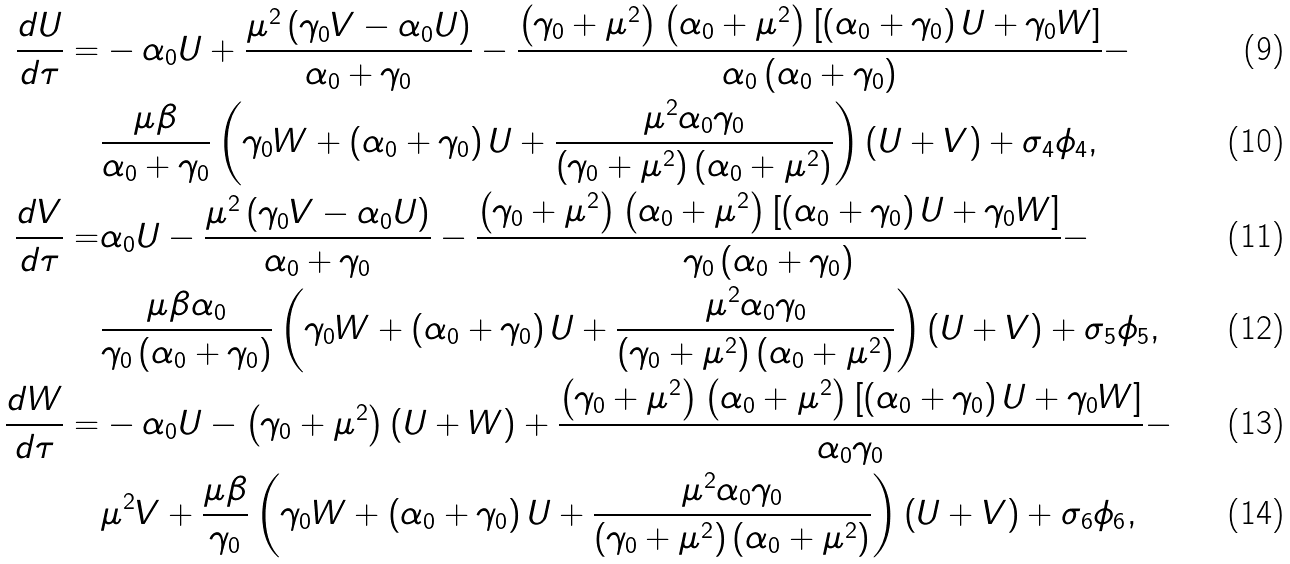Convert formula to latex. <formula><loc_0><loc_0><loc_500><loc_500>\frac { d U } { d \tau } = & - \alpha _ { 0 } U + { \frac { \mu ^ { 2 } \left ( \gamma _ { 0 } V - \alpha _ { 0 } U \right ) } { \alpha _ { 0 } + \gamma _ { 0 } } } - { \frac { \left ( \gamma _ { 0 } + \mu ^ { 2 } \right ) \left ( \alpha _ { 0 } + \mu ^ { 2 } \right ) \left [ \left ( \alpha _ { 0 } + \gamma _ { 0 } \right ) U + \gamma _ { 0 } W \right ] } { \alpha _ { 0 } \left ( \alpha _ { 0 } + \gamma _ { 0 } \right ) } } - \\ & \frac { \mu \beta } { \alpha _ { 0 } + \gamma _ { 0 } } \left ( \gamma _ { 0 } W + \left ( \alpha _ { 0 } + \gamma _ { 0 } \right ) U + { \frac { \mu ^ { 2 } \alpha _ { 0 } \gamma _ { 0 } } { \left ( \gamma _ { 0 } + \mu ^ { 2 } \right ) \left ( \alpha _ { 0 } + \mu ^ { 2 } \right ) } } \right ) \left ( U + V \right ) + \sigma _ { 4 } \phi _ { 4 } , \\ \frac { d V } { d \tau } = & \alpha _ { 0 } U - { \frac { \mu ^ { 2 } \left ( \gamma _ { 0 } V - \alpha _ { 0 } U \right ) } { \alpha _ { 0 } + \gamma _ { 0 } } } - { \frac { \left ( \gamma _ { 0 } + \mu ^ { 2 } \right ) \left ( \alpha _ { 0 } + \mu ^ { 2 } \right ) \left [ \left ( \alpha _ { 0 } + \gamma _ { 0 } \right ) U + \gamma _ { 0 } W \right ] } { \gamma _ { 0 } \left ( \alpha _ { 0 } + \gamma _ { 0 } \right ) } } - \\ & \frac { \mu \beta \alpha _ { 0 } } { \gamma _ { 0 } \left ( \alpha _ { 0 } + \gamma _ { 0 } \right ) } \left ( \gamma _ { 0 } W + \left ( \alpha _ { 0 } + \gamma _ { 0 } \right ) U + { \frac { \mu ^ { 2 } \alpha _ { 0 } \gamma _ { 0 } } { \left ( \gamma _ { 0 } + \mu ^ { 2 } \right ) \left ( \alpha _ { 0 } + \mu ^ { 2 } \right ) } } \right ) \left ( U + V \right ) + \sigma _ { 5 } \phi _ { 5 } , \\ \frac { d W } { d \tau } = & - \alpha _ { 0 } U - \left ( \gamma _ { 0 } + \mu ^ { 2 } \right ) \left ( U + W \right ) + { \frac { \left ( \gamma _ { 0 } + \mu ^ { 2 } \right ) \left ( \alpha _ { 0 } + \mu ^ { 2 } \right ) \left [ \left ( \alpha _ { 0 } + \gamma _ { 0 } \right ) U + \gamma _ { 0 } W \right ] } { \alpha _ { 0 } \gamma _ { 0 } } } - \\ & \mu ^ { 2 } V + \frac { \mu \beta } { \gamma _ { 0 } } \left ( \gamma _ { 0 } W + \left ( \alpha _ { 0 } + \gamma _ { 0 } \right ) U + { \frac { \mu ^ { 2 } \alpha _ { 0 } \gamma _ { 0 } } { \left ( \gamma _ { 0 } + \mu ^ { 2 } \right ) \left ( \alpha _ { 0 } + \mu ^ { 2 } \right ) } } \right ) \left ( U + V \right ) + \sigma _ { 6 } \phi _ { 6 } ,</formula> 